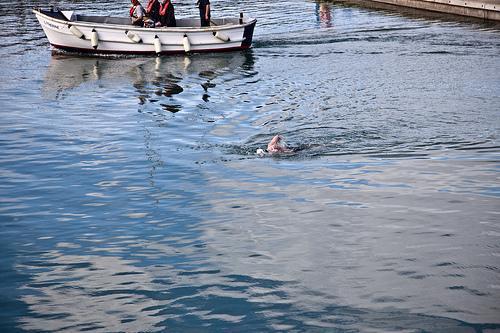How many people are seen swimming?
Give a very brief answer. 1. 